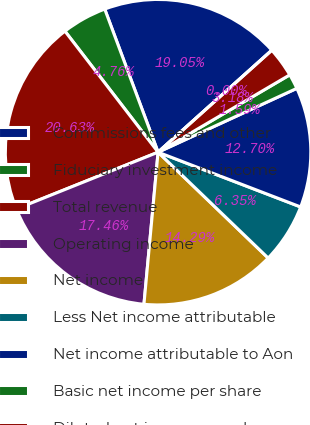<chart> <loc_0><loc_0><loc_500><loc_500><pie_chart><fcel>Commissions fees and other<fcel>Fiduciary investment income<fcel>Total revenue<fcel>Operating income<fcel>Net income<fcel>Less Net income attributable<fcel>Net income attributable to Aon<fcel>Basic net income per share<fcel>Diluted net income per share<fcel>Dividends paid per share<nl><fcel>19.05%<fcel>4.76%<fcel>20.63%<fcel>17.46%<fcel>14.29%<fcel>6.35%<fcel>12.7%<fcel>1.59%<fcel>3.18%<fcel>0.0%<nl></chart> 